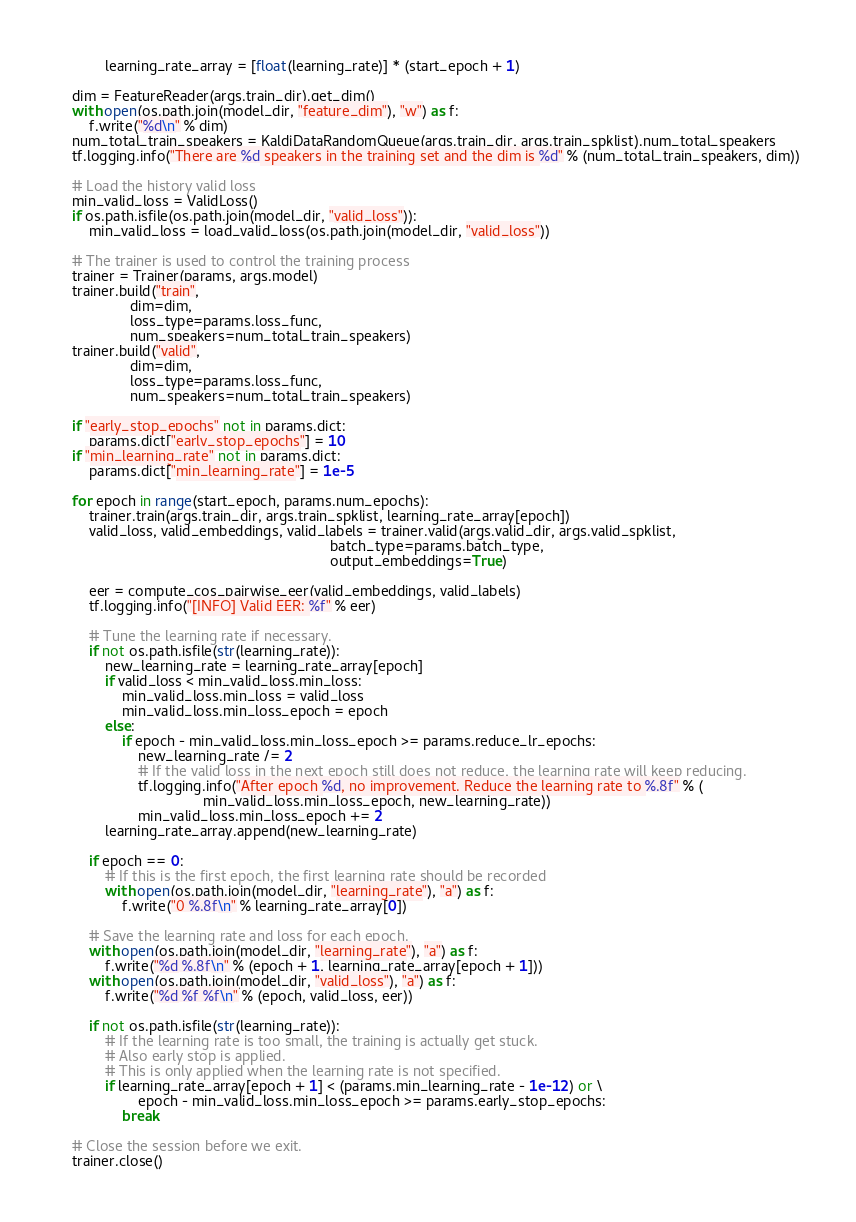Convert code to text. <code><loc_0><loc_0><loc_500><loc_500><_Python_>            learning_rate_array = [float(learning_rate)] * (start_epoch + 1)

    dim = FeatureReader(args.train_dir).get_dim()
    with open(os.path.join(model_dir, "feature_dim"), "w") as f:
        f.write("%d\n" % dim)
    num_total_train_speakers = KaldiDataRandomQueue(args.train_dir, args.train_spklist).num_total_speakers
    tf.logging.info("There are %d speakers in the training set and the dim is %d" % (num_total_train_speakers, dim))

    # Load the history valid loss
    min_valid_loss = ValidLoss()
    if os.path.isfile(os.path.join(model_dir, "valid_loss")):
        min_valid_loss = load_valid_loss(os.path.join(model_dir, "valid_loss"))

    # The trainer is used to control the training process
    trainer = Trainer(params, args.model)
    trainer.build("train",
                  dim=dim,
                  loss_type=params.loss_func,
                  num_speakers=num_total_train_speakers)
    trainer.build("valid",
                  dim=dim,
                  loss_type=params.loss_func,
                  num_speakers=num_total_train_speakers)

    if "early_stop_epochs" not in params.dict:
        params.dict["early_stop_epochs"] = 10
    if "min_learning_rate" not in params.dict:
        params.dict["min_learning_rate"] = 1e-5

    for epoch in range(start_epoch, params.num_epochs):
        trainer.train(args.train_dir, args.train_spklist, learning_rate_array[epoch])
        valid_loss, valid_embeddings, valid_labels = trainer.valid(args.valid_dir, args.valid_spklist,
                                                                   batch_type=params.batch_type,
                                                                   output_embeddings=True)

        eer = compute_cos_pairwise_eer(valid_embeddings, valid_labels)
        tf.logging.info("[INFO] Valid EER: %f" % eer)

        # Tune the learning rate if necessary.
        if not os.path.isfile(str(learning_rate)):
            new_learning_rate = learning_rate_array[epoch]
            if valid_loss < min_valid_loss.min_loss:
                min_valid_loss.min_loss = valid_loss
                min_valid_loss.min_loss_epoch = epoch
            else:
                if epoch - min_valid_loss.min_loss_epoch >= params.reduce_lr_epochs:
                    new_learning_rate /= 2
                    # If the valid loss in the next epoch still does not reduce, the learning rate will keep reducing.
                    tf.logging.info("After epoch %d, no improvement. Reduce the learning rate to %.8f" % (
                                    min_valid_loss.min_loss_epoch, new_learning_rate))
                    min_valid_loss.min_loss_epoch += 2
            learning_rate_array.append(new_learning_rate)

        if epoch == 0:
            # If this is the first epoch, the first learning rate should be recorded
            with open(os.path.join(model_dir, "learning_rate"), "a") as f:
                f.write("0 %.8f\n" % learning_rate_array[0])

        # Save the learning rate and loss for each epoch.
        with open(os.path.join(model_dir, "learning_rate"), "a") as f:
            f.write("%d %.8f\n" % (epoch + 1, learning_rate_array[epoch + 1]))
        with open(os.path.join(model_dir, "valid_loss"), "a") as f:
            f.write("%d %f %f\n" % (epoch, valid_loss, eer))

        if not os.path.isfile(str(learning_rate)):
            # If the learning rate is too small, the training is actually get stuck.
            # Also early stop is applied.
            # This is only applied when the learning rate is not specified.
            if learning_rate_array[epoch + 1] < (params.min_learning_rate - 1e-12) or \
                    epoch - min_valid_loss.min_loss_epoch >= params.early_stop_epochs:
                break

    # Close the session before we exit.
    trainer.close()
</code> 